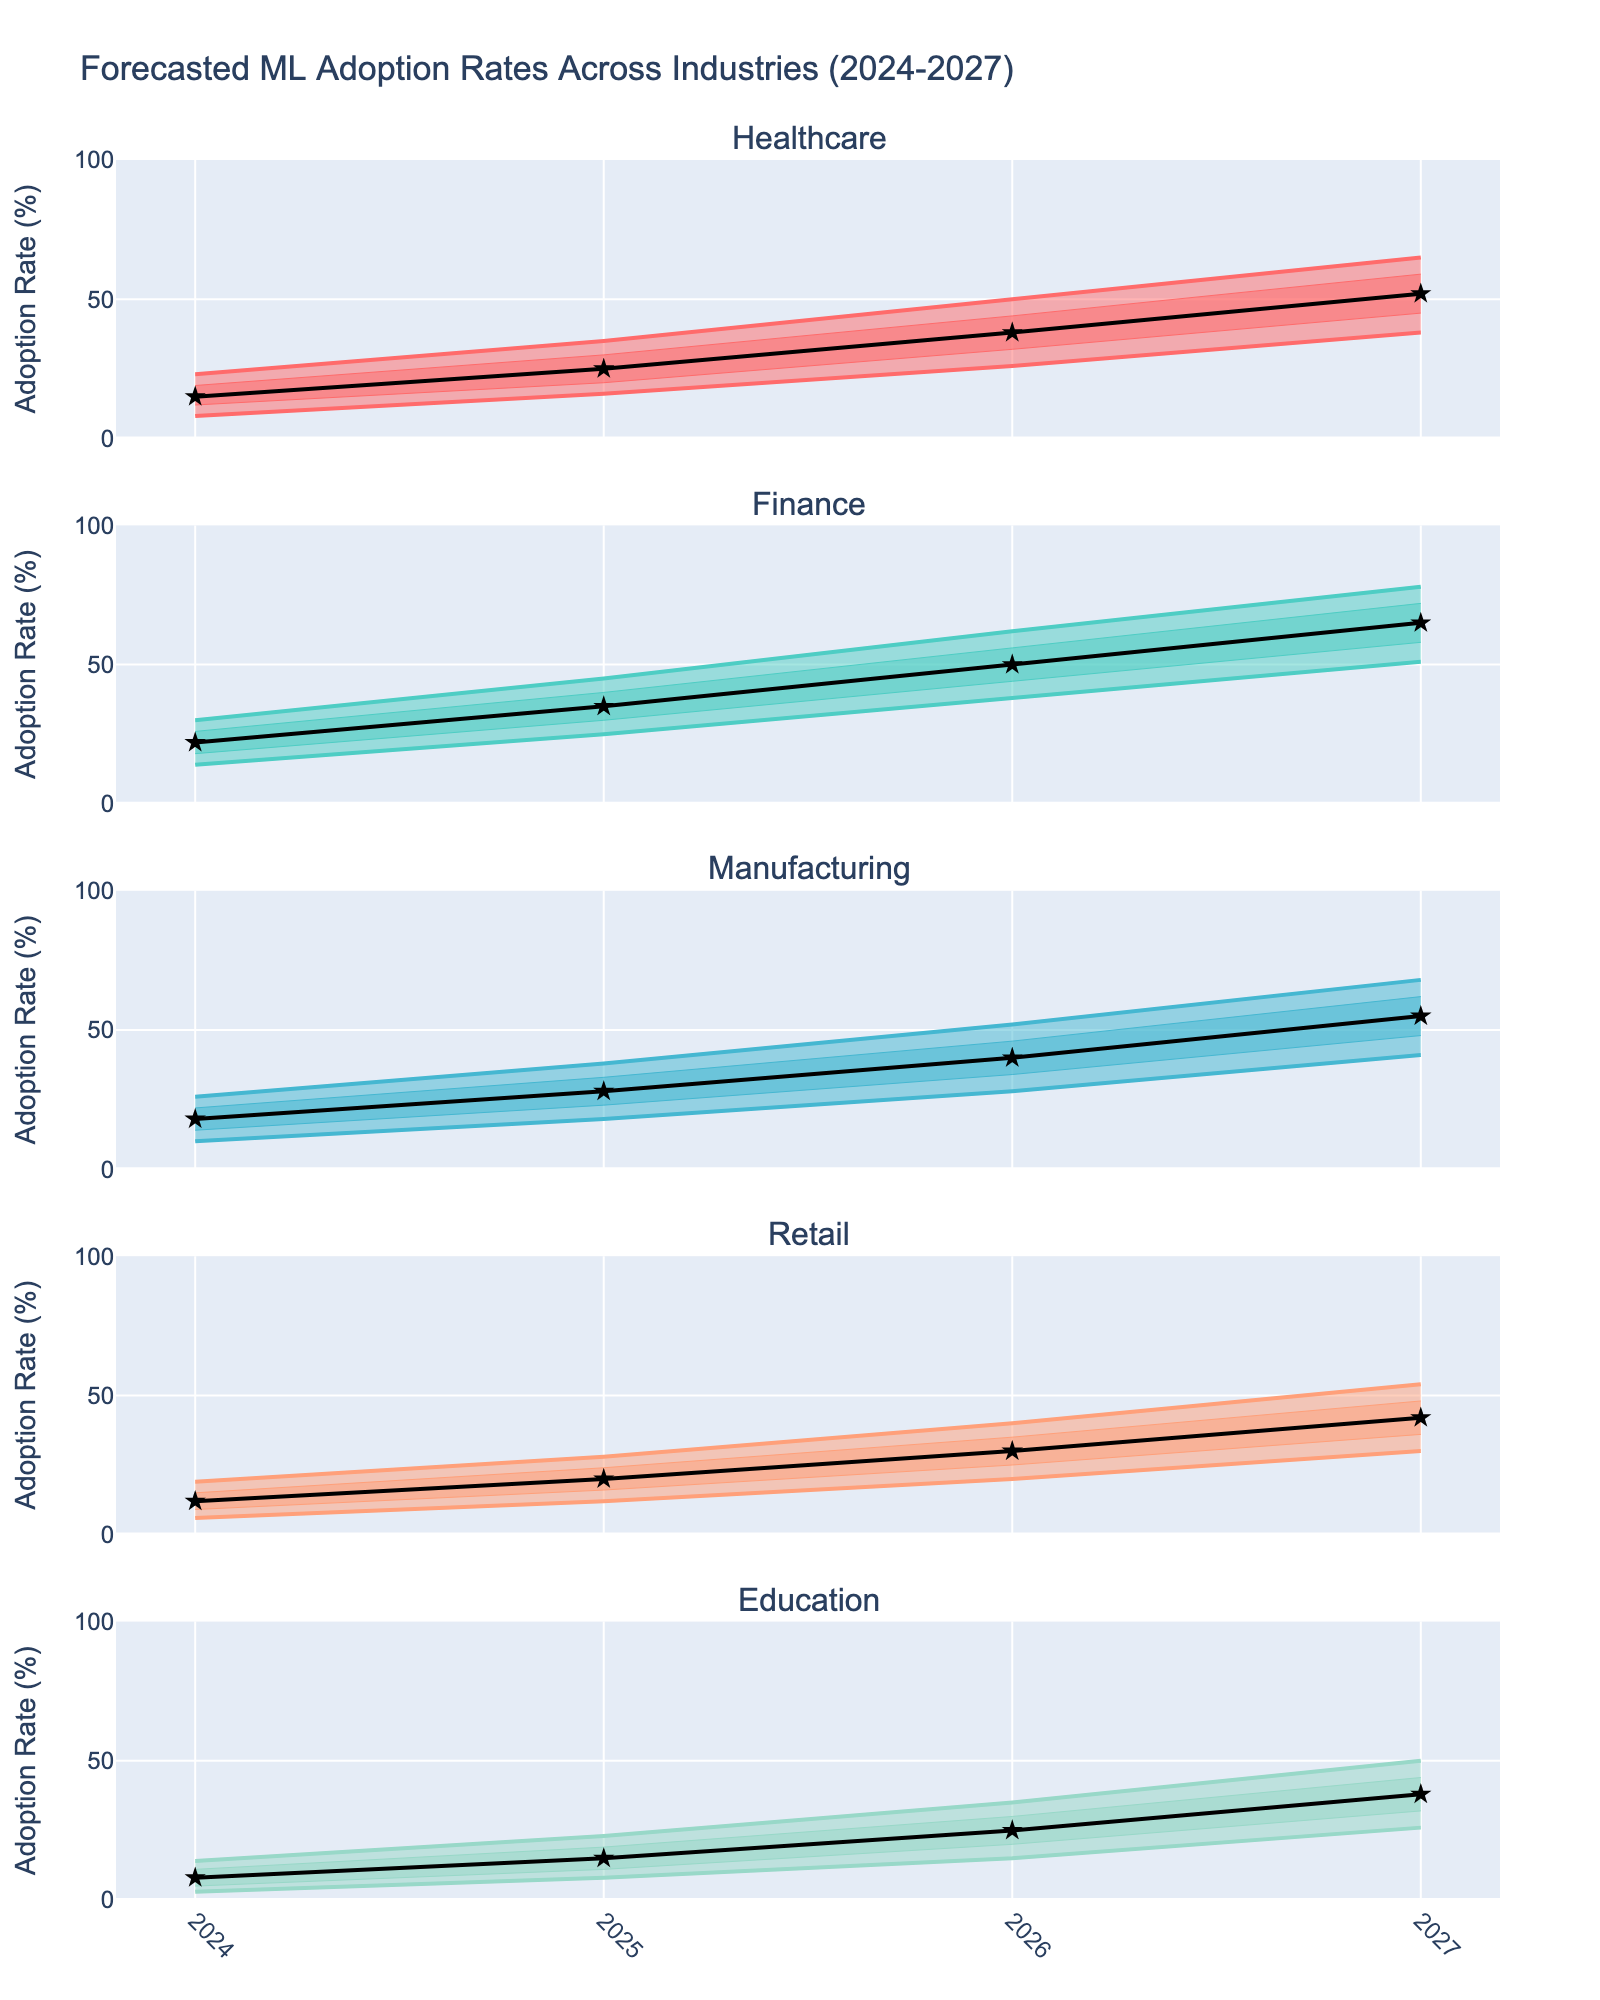what is the median forecasted adoption rate for Finance in 2025? To find this, look at the specific year 2025 for the Finance industry and find the median line value
Answer: 35% how many industries are represented in the chart? Count the distinct subplot titles representing each industry
Answer: 5 which industry has the lowest median adoption rate in 2026? Look at the median markers for each industry in 2026, compare, and identify the lowest value
Answer: Education which industry shows the highest predicted variability in adoption rates by 2027? Compare the range between the upper 90th percentile and lower 10th percentile for each industry in 2027
Answer: Finance what is the upper 75th percentile for Retail in 2024? Look directly at the data point on the plot that reflects the upper 75th percentile line for Retail in 2024
Answer: 15% what is the difference between the median adoption rates of Healthcare and Manufacturing in 2027? Check the median lines for Healthcare and Manufacturing in 2027, then subtract the Manufacturing median from the Healthcare median
Answer: 52-55 = -3 in which year does the Finance industry reach an upper 90th percentile adoption rate of above 60%? Look at the upper 90th percentile (the highest range line) for the Finance industry and identify the first year it exceeds 60%
Answer: 2027 how does the adoption rate trajectory compare between Retail and Healthcare from 2024 to 2027? Examine the median lines for both Retail and Healthcare from 2024 to 2027 to identify whether they increase, decrease, or remain stable
Answer: Both increase, Healthcare grows faster which industry has the narrowest predicted range (i.e., less variability) in 2025? Check the difference between the upper 90th percentile and lower 10th percentile across industries for 2025, and identify the narrowest range
Answer: Education 